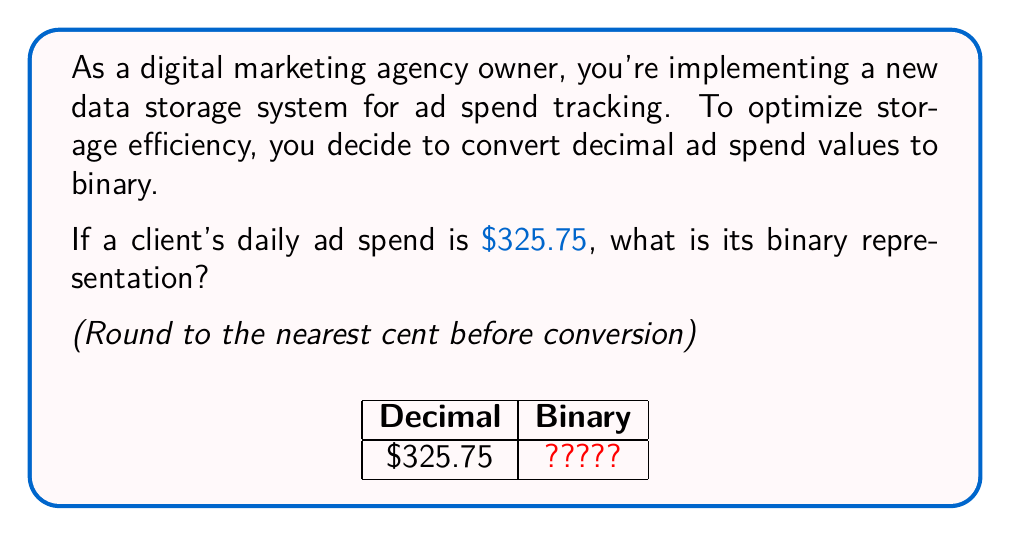Teach me how to tackle this problem. Let's approach this step-by-step:

1) First, round $325.75 to the nearest cent: $325.75

2) To convert to binary, we need to separate the integer and fractional parts:
   Integer part: 325
   Fractional part: 0.75

3) Convert the integer part (325) to binary:
   
   $$325 \div 2 = 162 \text{ remainder } 1$$
   $$162 \div 2 = 81 \text{ remainder } 0$$
   $$81 \div 2 = 40 \text{ remainder } 1$$
   $$40 \div 2 = 20 \text{ remainder } 0$$
   $$20 \div 2 = 10 \text{ remainder } 0$$
   $$10 \div 2 = 5 \text{ remainder } 0$$
   $$5 \div 2 = 2 \text{ remainder } 1$$
   $$2 \div 2 = 1 \text{ remainder } 0$$
   $$1 \div 2 = 0 \text{ remainder } 1$$

   Reading the remainders from bottom to top: 101000101

4) Convert the fractional part (0.75) to binary:
   
   $$0.75 \times 2 = 1.50 \rightarrow 1$$
   $$0.50 \times 2 = 1.00 \rightarrow 1$$

   Reading the integers: 0.11

5) Combine the results: 101000101.11

Therefore, $325.75 in binary is 101000101.11
Answer: 101000101.11 